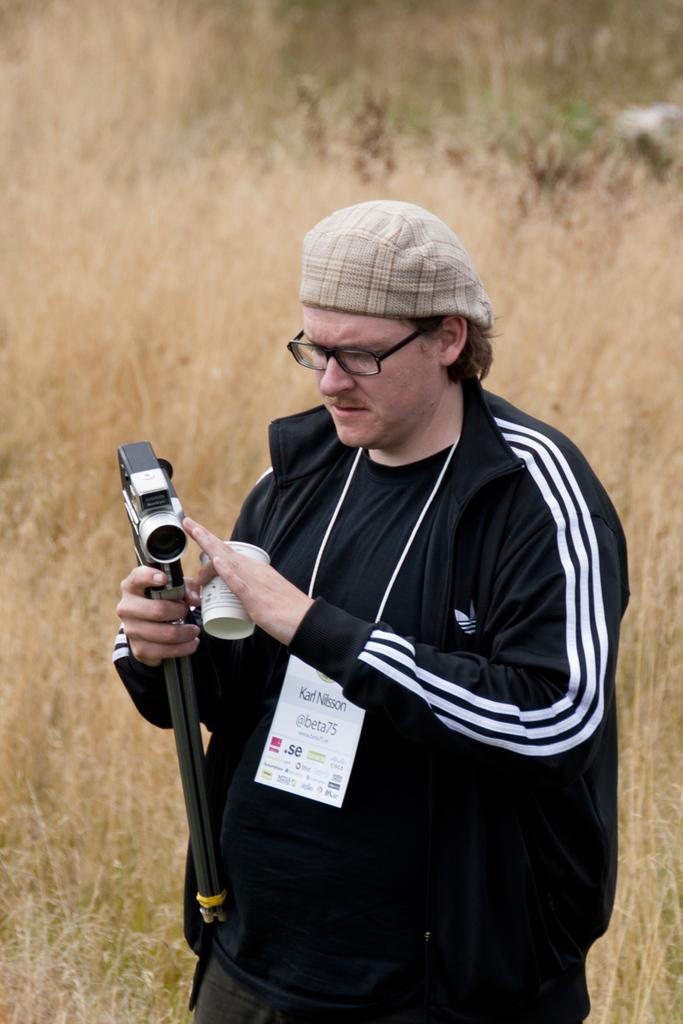In one or two sentences, can you explain what this image depicts? This picture shows a man standing and holding a handycam in his hand and he hold the cup in other hand 